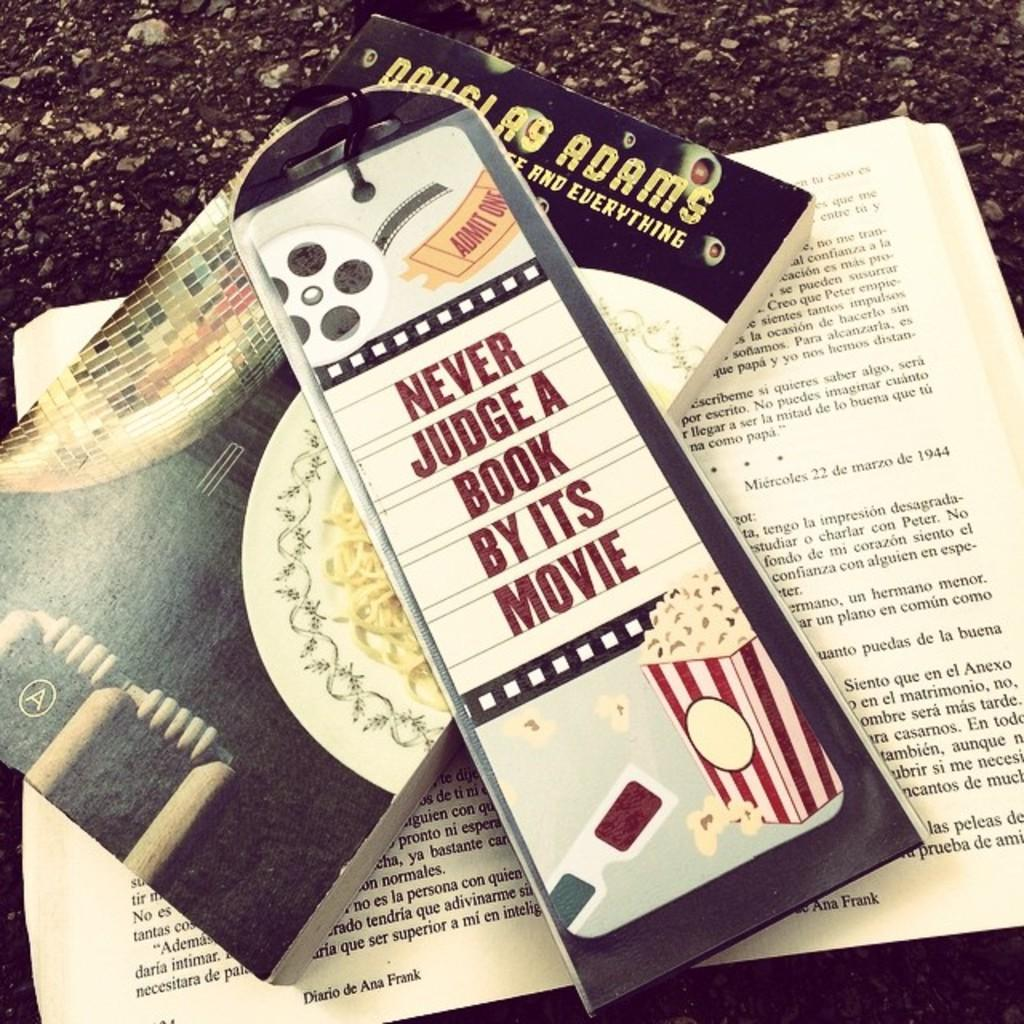<image>
Offer a succinct explanation of the picture presented. A couple books and the top one saying never judge a book by its movie 